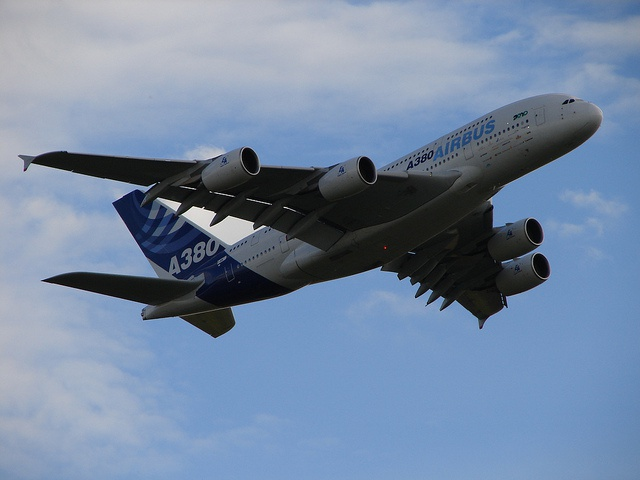Describe the objects in this image and their specific colors. I can see a airplane in darkgray, black, gray, and navy tones in this image. 